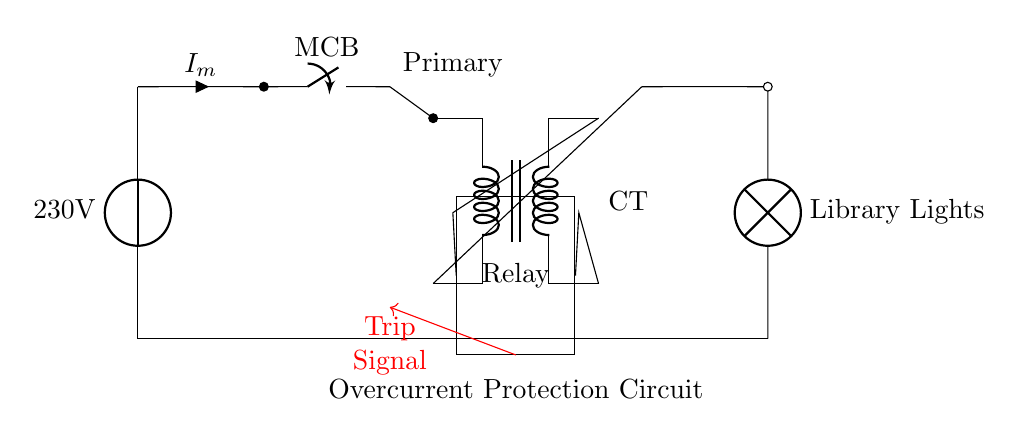What is the voltage of this circuit? The voltage of the circuit is 230 volts, which is indicated by the voltage source labeled accordingly.
Answer: 230 volts What component is used for current sensing? The current transformer, shown between the main circuit breaker and the relay, is used for detecting the current in the circuit.
Answer: Current transformer What does the relay do in this circuit? The relay functions as a switch that opens or closes based on the trip signal from the current transformer, protecting against overcurrent.
Answer: Switch How many main parts are in this overcurrent protection circuit? The circuit consists of three main parts: the main circuit breaker, the current transformer, and the relay.
Answer: Three What is the purpose of the trip signal? The trip signal is a control signal that activates the relay to cut off the circuit when overcurrent is detected.
Answer: Cut off the circuit What type of load is connected in this circuit? The load connected is a lighting load, specifically for the library lights as indicated in the circuit.
Answer: Library lights What happens when the current exceeds a certain limit? When the current exceeds the limit, the current transformer sends a trip signal to the relay, causing it to disconnect the circuit to prevent damage.
Answer: Disconnect the circuit 